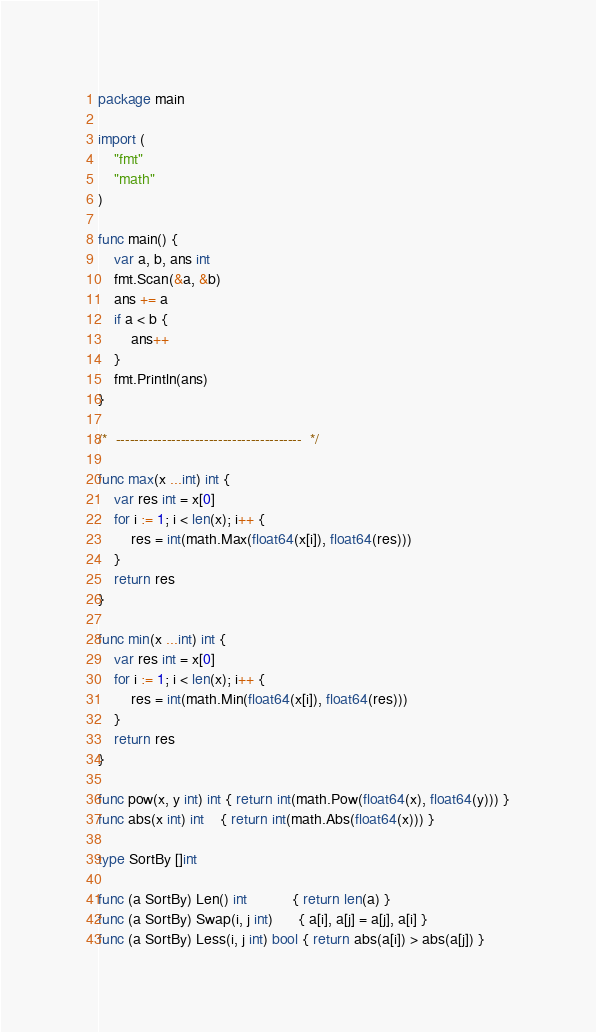<code> <loc_0><loc_0><loc_500><loc_500><_Go_>package main

import (
	"fmt"
	"math"
)

func main() {
	var a, b, ans int
	fmt.Scan(&a, &b)
	ans += a
	if a < b {
		ans++
	}
	fmt.Println(ans)
}

/*  ----------------------------------------  */

func max(x ...int) int {
	var res int = x[0]
	for i := 1; i < len(x); i++ {
		res = int(math.Max(float64(x[i]), float64(res)))
	}
	return res
}

func min(x ...int) int {
	var res int = x[0]
	for i := 1; i < len(x); i++ {
		res = int(math.Min(float64(x[i]), float64(res)))
	}
	return res
}

func pow(x, y int) int { return int(math.Pow(float64(x), float64(y))) }
func abs(x int) int    { return int(math.Abs(float64(x))) }

type SortBy []int

func (a SortBy) Len() int           { return len(a) }
func (a SortBy) Swap(i, j int)      { a[i], a[j] = a[j], a[i] }
func (a SortBy) Less(i, j int) bool { return abs(a[i]) > abs(a[j]) }
</code> 